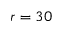<formula> <loc_0><loc_0><loc_500><loc_500>r = 3 0</formula> 